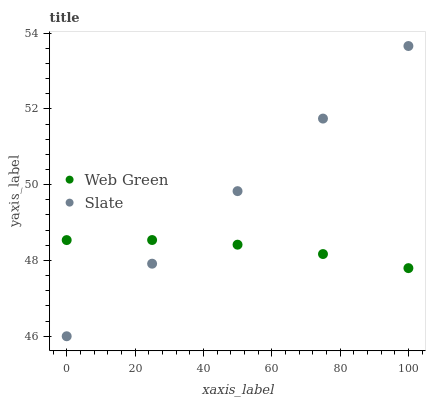Does Web Green have the minimum area under the curve?
Answer yes or no. Yes. Does Slate have the maximum area under the curve?
Answer yes or no. Yes. Does Web Green have the maximum area under the curve?
Answer yes or no. No. Is Slate the smoothest?
Answer yes or no. Yes. Is Web Green the roughest?
Answer yes or no. Yes. Is Web Green the smoothest?
Answer yes or no. No. Does Slate have the lowest value?
Answer yes or no. Yes. Does Web Green have the lowest value?
Answer yes or no. No. Does Slate have the highest value?
Answer yes or no. Yes. Does Web Green have the highest value?
Answer yes or no. No. Does Web Green intersect Slate?
Answer yes or no. Yes. Is Web Green less than Slate?
Answer yes or no. No. Is Web Green greater than Slate?
Answer yes or no. No. 